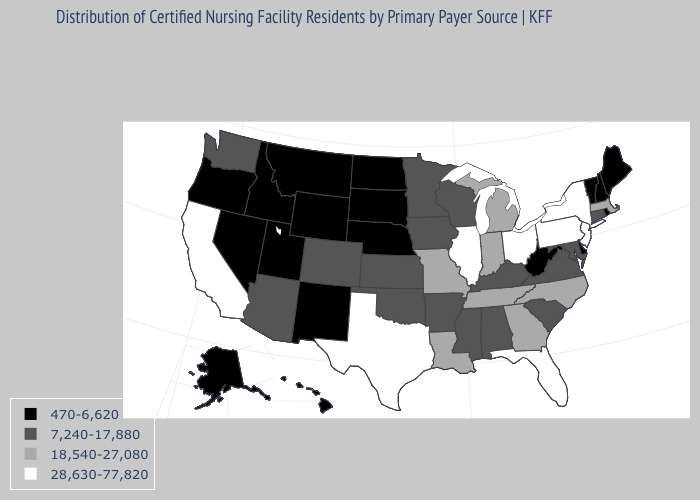Name the states that have a value in the range 470-6,620?
Concise answer only. Alaska, Delaware, Hawaii, Idaho, Maine, Montana, Nebraska, Nevada, New Hampshire, New Mexico, North Dakota, Oregon, Rhode Island, South Dakota, Utah, Vermont, West Virginia, Wyoming. Does Nebraska have a lower value than Louisiana?
Short answer required. Yes. Name the states that have a value in the range 470-6,620?
Quick response, please. Alaska, Delaware, Hawaii, Idaho, Maine, Montana, Nebraska, Nevada, New Hampshire, New Mexico, North Dakota, Oregon, Rhode Island, South Dakota, Utah, Vermont, West Virginia, Wyoming. Name the states that have a value in the range 470-6,620?
Concise answer only. Alaska, Delaware, Hawaii, Idaho, Maine, Montana, Nebraska, Nevada, New Hampshire, New Mexico, North Dakota, Oregon, Rhode Island, South Dakota, Utah, Vermont, West Virginia, Wyoming. Name the states that have a value in the range 28,630-77,820?
Short answer required. California, Florida, Illinois, New Jersey, New York, Ohio, Pennsylvania, Texas. Among the states that border Louisiana , does Mississippi have the lowest value?
Write a very short answer. Yes. What is the value of Wyoming?
Be succinct. 470-6,620. How many symbols are there in the legend?
Give a very brief answer. 4. Name the states that have a value in the range 28,630-77,820?
Answer briefly. California, Florida, Illinois, New Jersey, New York, Ohio, Pennsylvania, Texas. What is the lowest value in states that border New Hampshire?
Write a very short answer. 470-6,620. What is the value of Rhode Island?
Concise answer only. 470-6,620. What is the value of Maine?
Short answer required. 470-6,620. Among the states that border Tennessee , which have the lowest value?
Keep it brief. Alabama, Arkansas, Kentucky, Mississippi, Virginia. 